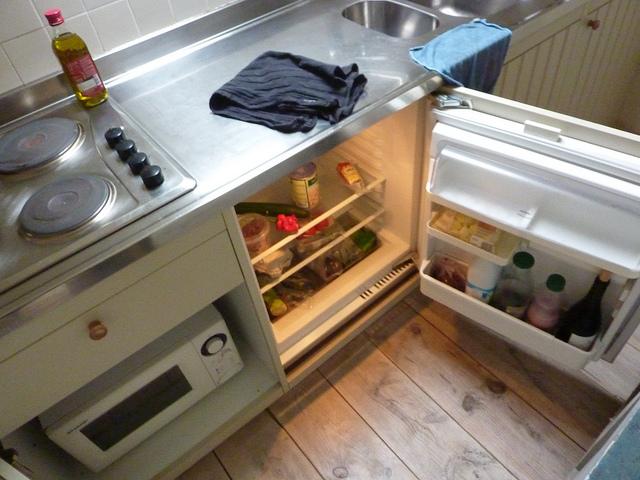Is there cooking oil on the counter?
Quick response, please. Yes. What kind of room is this?
Answer briefly. Kitchen. Is the counter messy?
Keep it brief. No. What kind floor is the refrigerator on?
Short answer required. Wood. Is the refrigerator door closed?
Short answer required. No. 